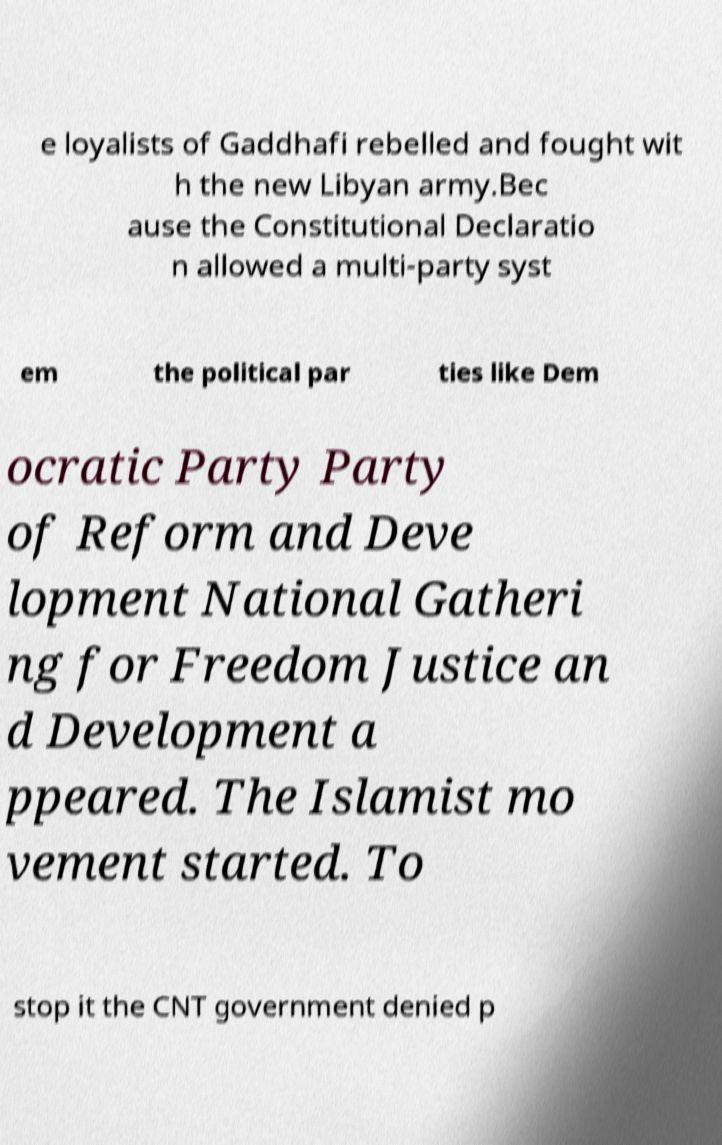Can you accurately transcribe the text from the provided image for me? e loyalists of Gaddhafi rebelled and fought wit h the new Libyan army.Bec ause the Constitutional Declaratio n allowed a multi-party syst em the political par ties like Dem ocratic Party Party of Reform and Deve lopment National Gatheri ng for Freedom Justice an d Development a ppeared. The Islamist mo vement started. To stop it the CNT government denied p 